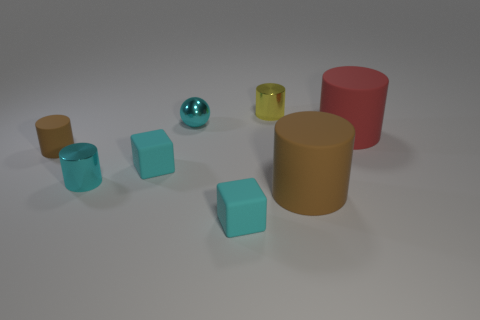Are there any objects that match the texture and shine of the turquoise cubes? Yes, there is one object that shares the shiny texture with the turquoise cubes. It is a small, reflective, teal sphere situated to the left of the group of cylinders. Do the colors of the cylinders represent anything specific? Without additional context, it's hard to determine if the colors of the cylinders have a specific representation. They might simply be chosen for aesthetic variety, or they could be part of a color-coded system in a particular setting. Without more information, any interpretation would be purely speculative. 